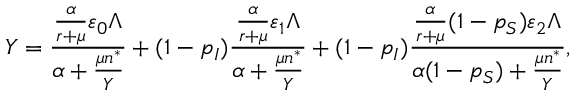<formula> <loc_0><loc_0><loc_500><loc_500>Y = \frac { \frac { \alpha } { r + \mu } \varepsilon _ { 0 } \Lambda } { \alpha + \frac { \mu n ^ { * } } { Y } } + ( 1 - p _ { I } ) \frac { \frac { \alpha } { r + \mu } \varepsilon _ { 1 } \Lambda } { \alpha + \frac { \mu n ^ { * } } { Y } } + ( 1 - p _ { I } ) \frac { \frac { \alpha } { r + \mu } ( 1 - p _ { S } ) \varepsilon _ { 2 } \Lambda } { \alpha ( 1 - p _ { S } ) + \frac { \mu n ^ { * } } { Y } } ,</formula> 